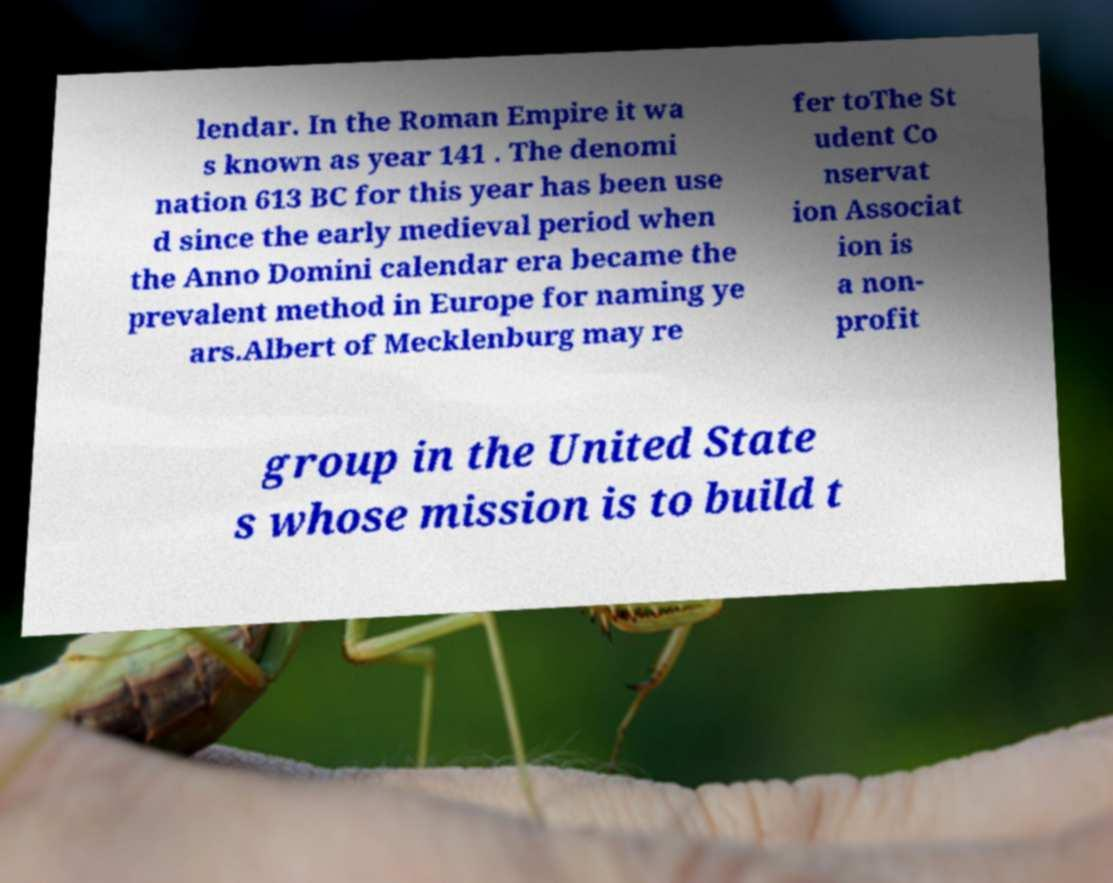Please read and relay the text visible in this image. What does it say? lendar. In the Roman Empire it wa s known as year 141 . The denomi nation 613 BC for this year has been use d since the early medieval period when the Anno Domini calendar era became the prevalent method in Europe for naming ye ars.Albert of Mecklenburg may re fer toThe St udent Co nservat ion Associat ion is a non- profit group in the United State s whose mission is to build t 